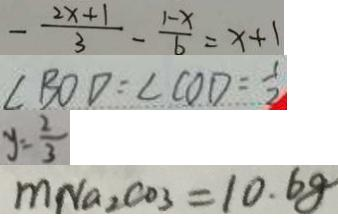Convert formula to latex. <formula><loc_0><loc_0><loc_500><loc_500>- \frac { 2 x + 1 } { 3 } - \frac { 1 - x } { 6 } = x + 1 
 \angle B O D = \angle C O D = \frac { 1 } { 2 } 
 y = \frac { 2 } { 3 } 
 m N a _ { 2 } C O _ { 3 } = 1 0 . 6 8</formula> 